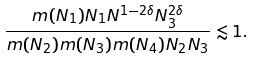Convert formula to latex. <formula><loc_0><loc_0><loc_500><loc_500>\frac { m ( N _ { 1 } ) N _ { 1 } N ^ { 1 - 2 \delta } N _ { 3 } ^ { 2 \delta } } { m ( N _ { 2 } ) m ( N _ { 3 } ) m ( N _ { 4 } ) N _ { 2 } N _ { 3 } } & \lesssim 1 .</formula> 